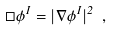Convert formula to latex. <formula><loc_0><loc_0><loc_500><loc_500>\Box \phi ^ { I } = | \nabla \phi ^ { I } | ^ { 2 } \ ,</formula> 